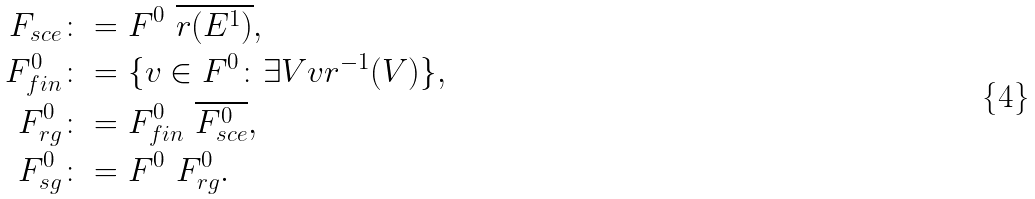Convert formula to latex. <formula><loc_0><loc_0><loc_500><loc_500>F _ { s c e } & \colon = F ^ { 0 } \ \overline { r ( E ^ { 1 } ) } , \\ F ^ { 0 } _ { f i n } & \colon = \{ v \in F ^ { 0 } \colon \exists V v r ^ { - 1 } ( V ) \} , \\ F ^ { 0 } _ { r g } & \colon = F ^ { 0 } _ { f i n } \ \overline { F ^ { 0 } _ { s c e } } , \\ F ^ { 0 } _ { s g } & \colon = F ^ { 0 } \ F ^ { 0 } _ { r g } .</formula> 